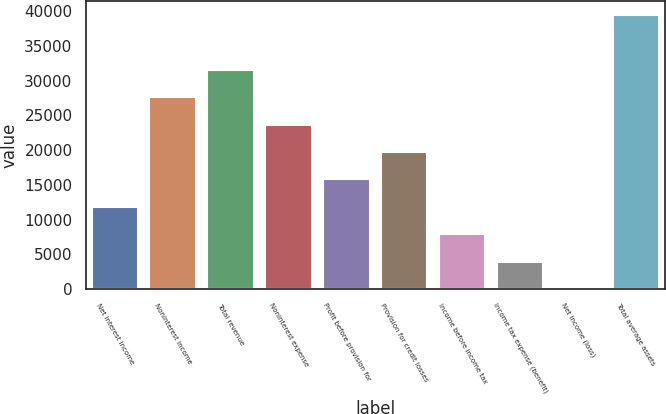<chart> <loc_0><loc_0><loc_500><loc_500><bar_chart><fcel>Net interest income<fcel>Noninterest income<fcel>Total revenue<fcel>Noninterest expense<fcel>Profit before provision for<fcel>Provision for credit losses<fcel>Income before income tax<fcel>Income tax expense (benefit)<fcel>Net income (loss)<fcel>Total average assets<nl><fcel>11827.3<fcel>27595.7<fcel>31537.8<fcel>23653.6<fcel>15769.4<fcel>19711.5<fcel>7885.2<fcel>3943.1<fcel>1<fcel>39422<nl></chart> 